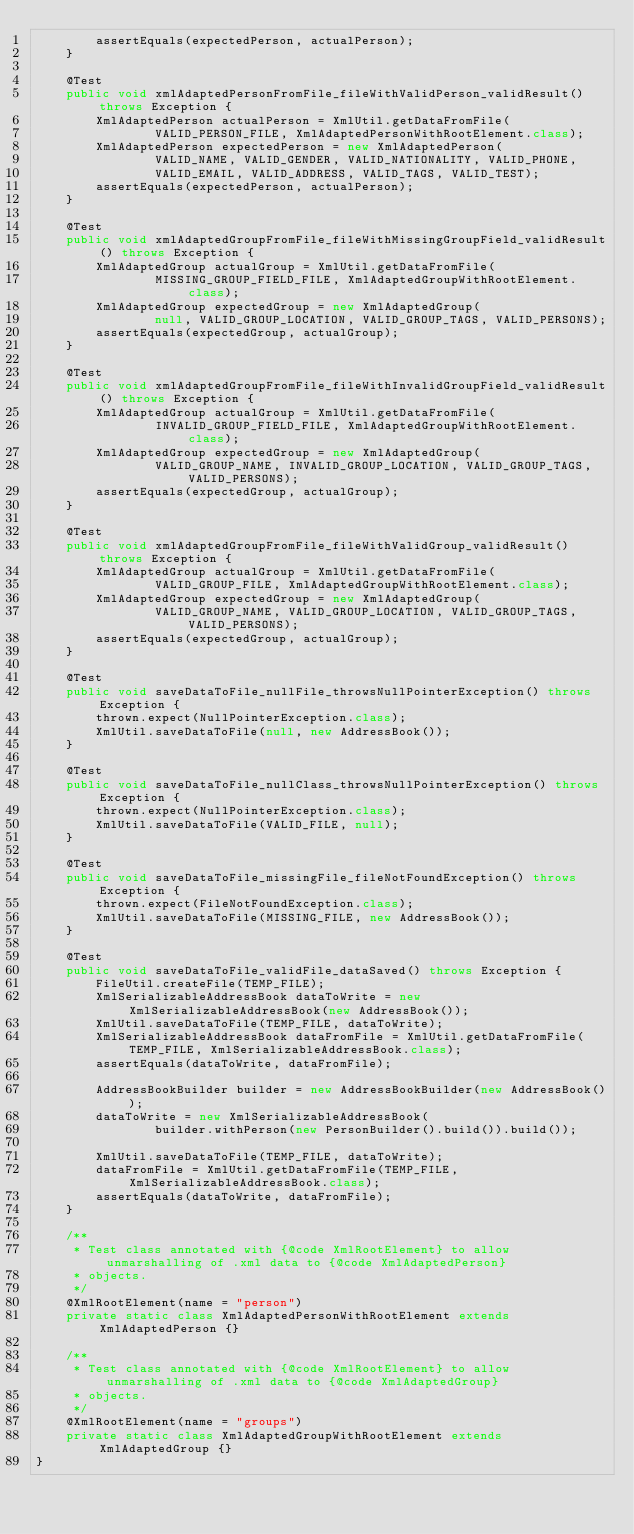<code> <loc_0><loc_0><loc_500><loc_500><_Java_>        assertEquals(expectedPerson, actualPerson);
    }

    @Test
    public void xmlAdaptedPersonFromFile_fileWithValidPerson_validResult() throws Exception {
        XmlAdaptedPerson actualPerson = XmlUtil.getDataFromFile(
                VALID_PERSON_FILE, XmlAdaptedPersonWithRootElement.class);
        XmlAdaptedPerson expectedPerson = new XmlAdaptedPerson(
                VALID_NAME, VALID_GENDER, VALID_NATIONALITY, VALID_PHONE,
                VALID_EMAIL, VALID_ADDRESS, VALID_TAGS, VALID_TEST);
        assertEquals(expectedPerson, actualPerson);
    }

    @Test
    public void xmlAdaptedGroupFromFile_fileWithMissingGroupField_validResult() throws Exception {
        XmlAdaptedGroup actualGroup = XmlUtil.getDataFromFile(
                MISSING_GROUP_FIELD_FILE, XmlAdaptedGroupWithRootElement.class);
        XmlAdaptedGroup expectedGroup = new XmlAdaptedGroup(
                null, VALID_GROUP_LOCATION, VALID_GROUP_TAGS, VALID_PERSONS);
        assertEquals(expectedGroup, actualGroup);
    }

    @Test
    public void xmlAdaptedGroupFromFile_fileWithInvalidGroupField_validResult() throws Exception {
        XmlAdaptedGroup actualGroup = XmlUtil.getDataFromFile(
                INVALID_GROUP_FIELD_FILE, XmlAdaptedGroupWithRootElement.class);
        XmlAdaptedGroup expectedGroup = new XmlAdaptedGroup(
                VALID_GROUP_NAME, INVALID_GROUP_LOCATION, VALID_GROUP_TAGS, VALID_PERSONS);
        assertEquals(expectedGroup, actualGroup);
    }

    @Test
    public void xmlAdaptedGroupFromFile_fileWithValidGroup_validResult() throws Exception {
        XmlAdaptedGroup actualGroup = XmlUtil.getDataFromFile(
                VALID_GROUP_FILE, XmlAdaptedGroupWithRootElement.class);
        XmlAdaptedGroup expectedGroup = new XmlAdaptedGroup(
                VALID_GROUP_NAME, VALID_GROUP_LOCATION, VALID_GROUP_TAGS, VALID_PERSONS);
        assertEquals(expectedGroup, actualGroup);
    }

    @Test
    public void saveDataToFile_nullFile_throwsNullPointerException() throws Exception {
        thrown.expect(NullPointerException.class);
        XmlUtil.saveDataToFile(null, new AddressBook());
    }

    @Test
    public void saveDataToFile_nullClass_throwsNullPointerException() throws Exception {
        thrown.expect(NullPointerException.class);
        XmlUtil.saveDataToFile(VALID_FILE, null);
    }

    @Test
    public void saveDataToFile_missingFile_fileNotFoundException() throws Exception {
        thrown.expect(FileNotFoundException.class);
        XmlUtil.saveDataToFile(MISSING_FILE, new AddressBook());
    }

    @Test
    public void saveDataToFile_validFile_dataSaved() throws Exception {
        FileUtil.createFile(TEMP_FILE);
        XmlSerializableAddressBook dataToWrite = new XmlSerializableAddressBook(new AddressBook());
        XmlUtil.saveDataToFile(TEMP_FILE, dataToWrite);
        XmlSerializableAddressBook dataFromFile = XmlUtil.getDataFromFile(TEMP_FILE, XmlSerializableAddressBook.class);
        assertEquals(dataToWrite, dataFromFile);

        AddressBookBuilder builder = new AddressBookBuilder(new AddressBook());
        dataToWrite = new XmlSerializableAddressBook(
                builder.withPerson(new PersonBuilder().build()).build());

        XmlUtil.saveDataToFile(TEMP_FILE, dataToWrite);
        dataFromFile = XmlUtil.getDataFromFile(TEMP_FILE, XmlSerializableAddressBook.class);
        assertEquals(dataToWrite, dataFromFile);
    }

    /**
     * Test class annotated with {@code XmlRootElement} to allow unmarshalling of .xml data to {@code XmlAdaptedPerson}
     * objects.
     */
    @XmlRootElement(name = "person")
    private static class XmlAdaptedPersonWithRootElement extends XmlAdaptedPerson {}

    /**
     * Test class annotated with {@code XmlRootElement} to allow unmarshalling of .xml data to {@code XmlAdaptedGroup}
     * objects.
     */
    @XmlRootElement(name = "groups")
    private static class XmlAdaptedGroupWithRootElement extends XmlAdaptedGroup {}
}
</code> 